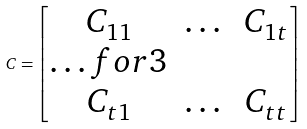<formula> <loc_0><loc_0><loc_500><loc_500>C = \begin{bmatrix} C _ { 1 1 } & \dots & C _ { 1 t } \\ \hdots f o r { 3 } \\ C _ { t 1 } & \dots & C _ { t t } \\ \end{bmatrix}</formula> 